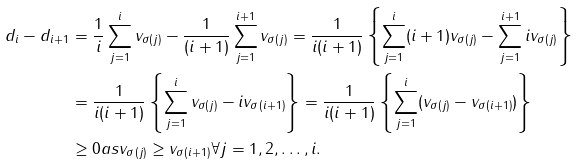<formula> <loc_0><loc_0><loc_500><loc_500>d _ { i } - d _ { i + 1 } & = \frac { 1 } { i } \sum _ { j = 1 } ^ { i } v _ { \sigma ( j ) } - \frac { 1 } { ( i + 1 ) } \sum _ { j = 1 } ^ { i + 1 } v _ { \sigma ( j ) } = \frac { 1 } { i ( i + 1 ) } \left \{ \sum _ { j = 1 } ^ { i } ( i + 1 ) v _ { \sigma ( j ) } - \sum _ { j = 1 } ^ { i + 1 } i v _ { \sigma ( j ) } \right \} \\ & = \frac { 1 } { i ( i + 1 ) } \left \{ \sum _ { j = 1 } ^ { i } v _ { \sigma ( j ) } - i v _ { \sigma ( i + 1 ) } \right \} = \frac { 1 } { i ( i + 1 ) } \left \{ \sum _ { j = 1 } ^ { i } ( v _ { \sigma ( j ) } - v _ { \sigma ( i + 1 ) } ) \right \} \\ & \geq 0 a s v _ { \sigma ( j ) } \geq v _ { \sigma ( i + 1 ) } \forall j = 1 , 2 , \dots , i .</formula> 